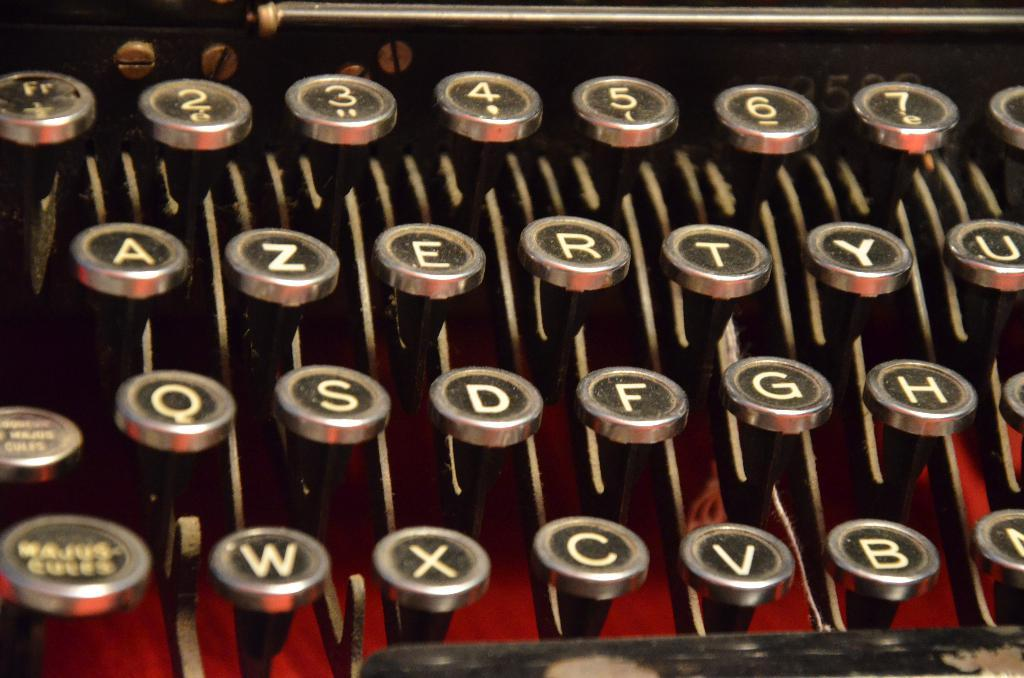Provide a one-sentence caption for the provided image. an old typewriter keys from A - U on the top row down to W - B on the bottom. 